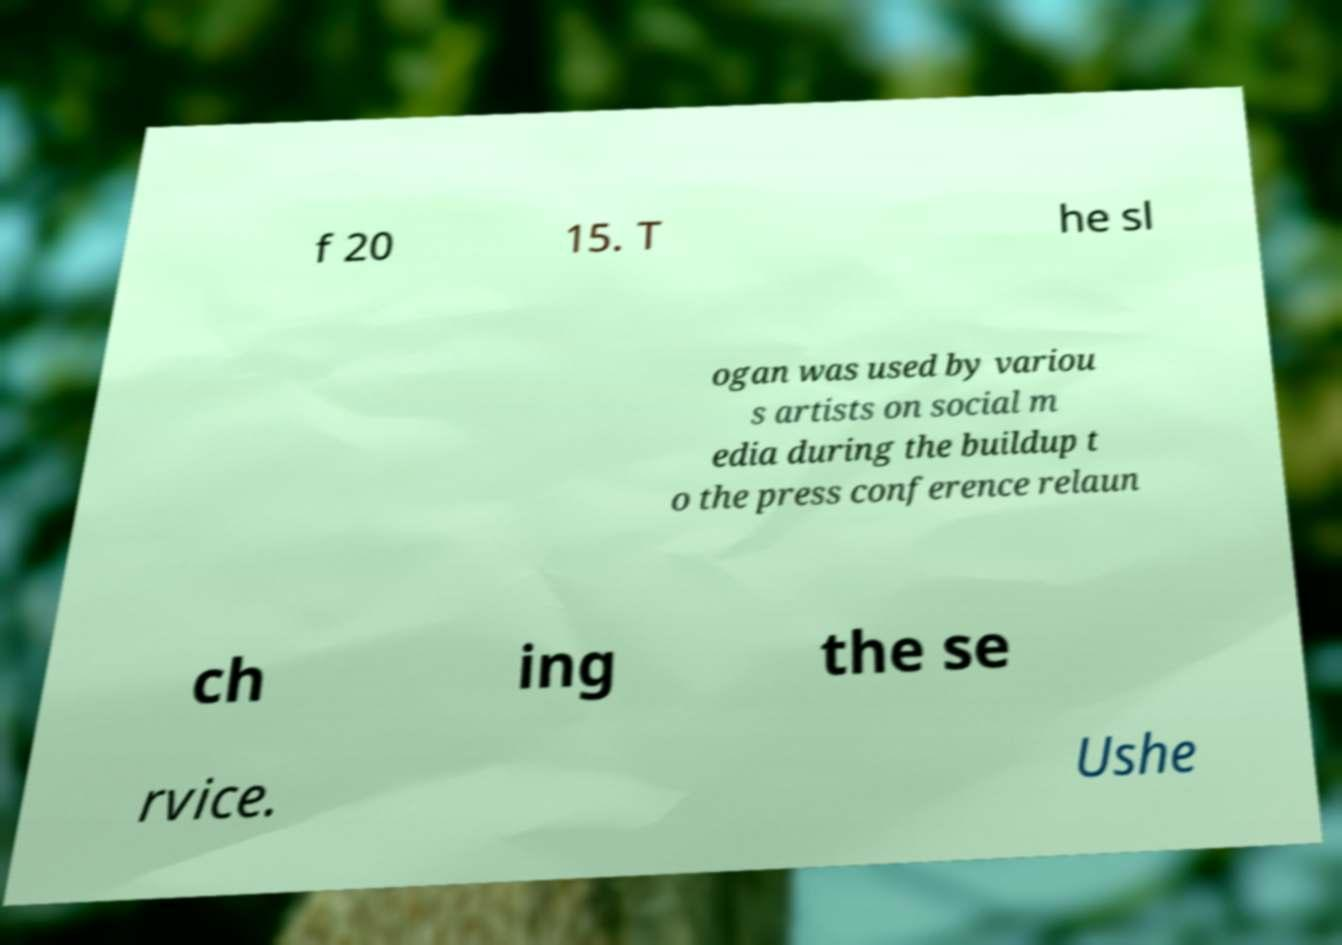Please identify and transcribe the text found in this image. f 20 15. T he sl ogan was used by variou s artists on social m edia during the buildup t o the press conference relaun ch ing the se rvice. Ushe 